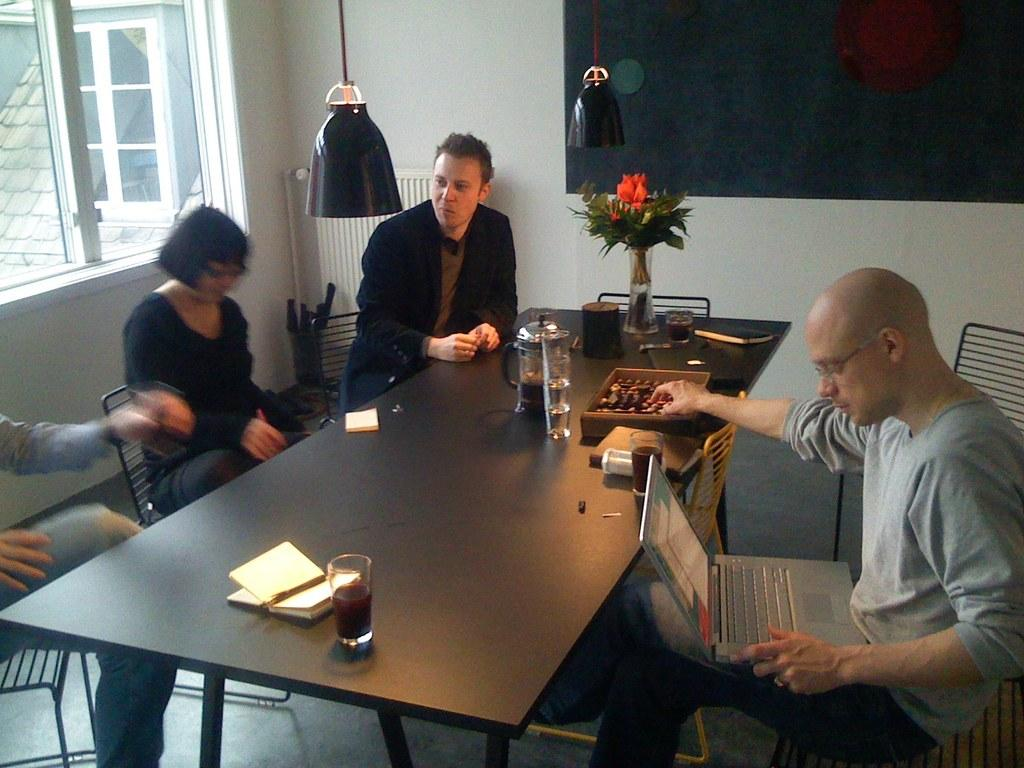How many people are in the image? There are four people in the image: three men and one woman. What are the people in the image doing? The men and woman are sitting on chairs. Is there any furniture in the image besides the chairs? Yes, there is a table in front of the chairs. What type of crib can be seen in the image? There is no crib present in the image. What is the occupation of the man in the image? The image does not specify the occupation of any person in the image. 